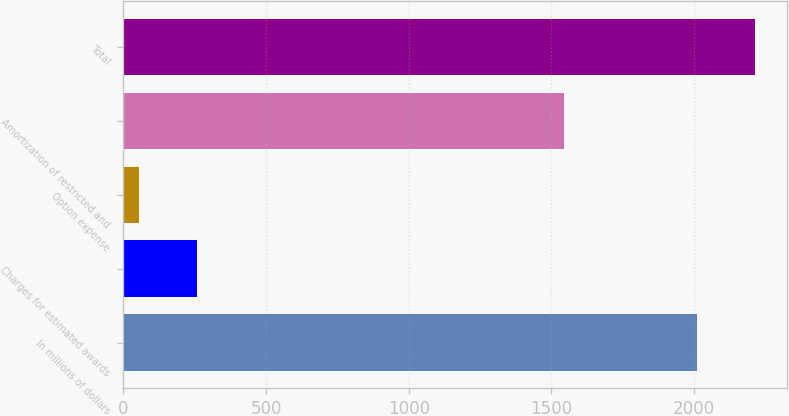Convert chart to OTSL. <chart><loc_0><loc_0><loc_500><loc_500><bar_chart><fcel>In millions of dollars<fcel>Charges for estimated awards<fcel>Option expense<fcel>Amortization of restricted and<fcel>Total<nl><fcel>2009<fcel>259.4<fcel>55<fcel>1543<fcel>2213.4<nl></chart> 